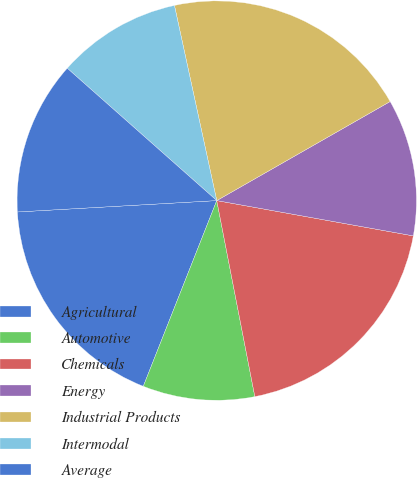<chart> <loc_0><loc_0><loc_500><loc_500><pie_chart><fcel>Agricultural<fcel>Automotive<fcel>Chemicals<fcel>Energy<fcel>Industrial Products<fcel>Intermodal<fcel>Average<nl><fcel>18.1%<fcel>9.05%<fcel>19.12%<fcel>11.09%<fcel>20.14%<fcel>10.07%<fcel>12.44%<nl></chart> 